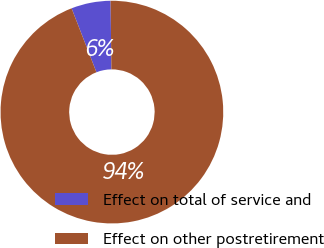<chart> <loc_0><loc_0><loc_500><loc_500><pie_chart><fcel>Effect on total of service and<fcel>Effect on other postretirement<nl><fcel>5.71%<fcel>94.29%<nl></chart> 